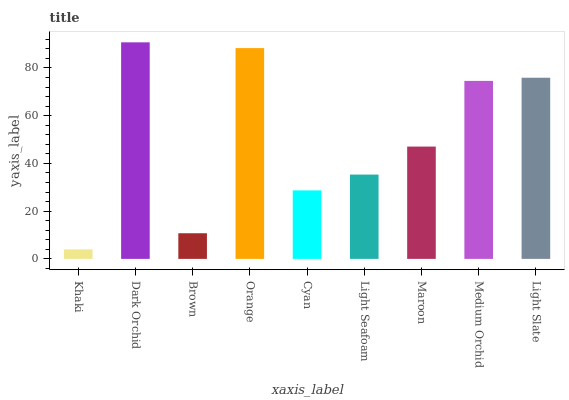Is Khaki the minimum?
Answer yes or no. Yes. Is Dark Orchid the maximum?
Answer yes or no. Yes. Is Brown the minimum?
Answer yes or no. No. Is Brown the maximum?
Answer yes or no. No. Is Dark Orchid greater than Brown?
Answer yes or no. Yes. Is Brown less than Dark Orchid?
Answer yes or no. Yes. Is Brown greater than Dark Orchid?
Answer yes or no. No. Is Dark Orchid less than Brown?
Answer yes or no. No. Is Maroon the high median?
Answer yes or no. Yes. Is Maroon the low median?
Answer yes or no. Yes. Is Light Slate the high median?
Answer yes or no. No. Is Medium Orchid the low median?
Answer yes or no. No. 